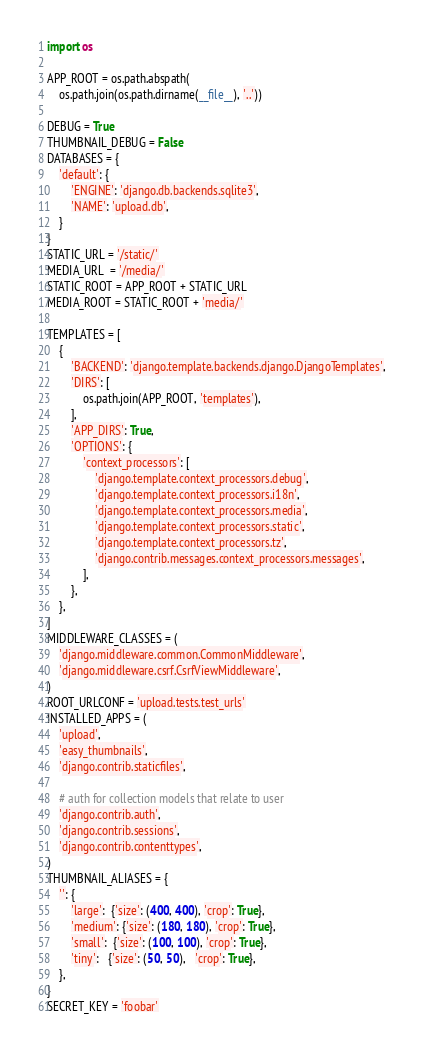Convert code to text. <code><loc_0><loc_0><loc_500><loc_500><_Python_>import os

APP_ROOT = os.path.abspath(
    os.path.join(os.path.dirname(__file__), '..'))

DEBUG = True
THUMBNAIL_DEBUG = False
DATABASES = {
    'default': {
        'ENGINE': 'django.db.backends.sqlite3',
        'NAME': 'upload.db',
    }
}
STATIC_URL = '/static/'
MEDIA_URL  = '/media/'
STATIC_ROOT = APP_ROOT + STATIC_URL
MEDIA_ROOT = STATIC_ROOT + 'media/'

TEMPLATES = [
    {
        'BACKEND': 'django.template.backends.django.DjangoTemplates',
        'DIRS': [
            os.path.join(APP_ROOT, 'templates'),
        ],
        'APP_DIRS': True,
        'OPTIONS': {
            'context_processors': [
                'django.template.context_processors.debug',
                'django.template.context_processors.i18n',
                'django.template.context_processors.media',
                'django.template.context_processors.static',
                'django.template.context_processors.tz',
                'django.contrib.messages.context_processors.messages',
            ],
        },
    },
]
MIDDLEWARE_CLASSES = (
    'django.middleware.common.CommonMiddleware',
    'django.middleware.csrf.CsrfViewMiddleware',
)
ROOT_URLCONF = 'upload.tests.test_urls'
INSTALLED_APPS = (
    'upload',
    'easy_thumbnails',
    'django.contrib.staticfiles',

    # auth for collection models that relate to user
    'django.contrib.auth',
    'django.contrib.sessions',
    'django.contrib.contenttypes',
)
THUMBNAIL_ALIASES = {
    '': {
        'large':  {'size': (400, 400), 'crop': True},
        'medium': {'size': (180, 180), 'crop': True},
        'small':  {'size': (100, 100), 'crop': True},
        'tiny':   {'size': (50, 50),   'crop': True},
    },
}
SECRET_KEY = 'foobar'
</code> 